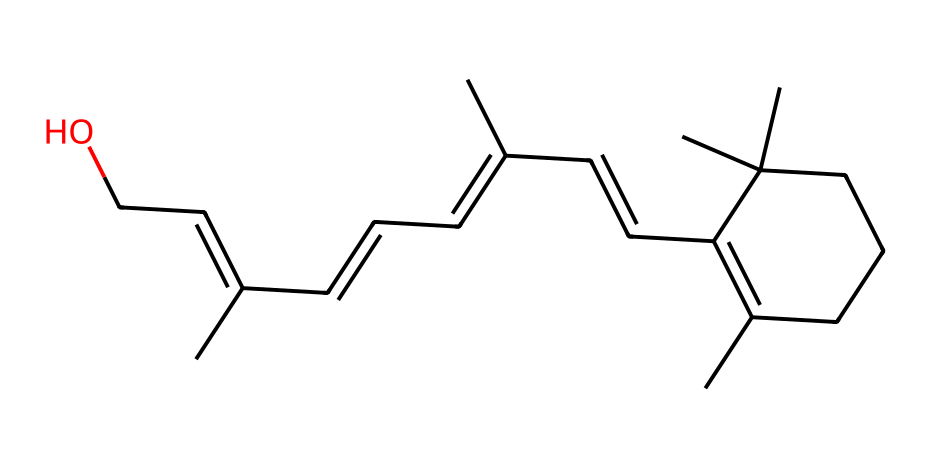What is the name of this chemical? The provided SMILES corresponds to retinol, which is commonly known as Vitamin A. The structure's overall arrangement and specific functional groups lead to its identification as retinol.
Answer: retinol How many carbon atoms are present in the structure? By analyzing the SMILES representation, you can count the number of 'C' characters in the chemical structure string. There are 20 carbon atoms in total.
Answer: 20 What functional group is present in this molecule? The molecule contains a hydroxyl (-OH) group, which is identified from the "C(CO)" part of the SMILES where 'O' indicates the presence of oxygen as part of the alcohol functional group.
Answer: hydroxyl How many double bonds are present in retinol? By examining the carbon-carbon connections in the structure, you can identify the presence of double bonds. In retinol, there are 5 double bonds between carbon atoms.
Answer: 5 Does this chemical dissolve in water? Since retinol is classified as a non-electrolyte, it has low solubility in water due to its hydrophobic carbon chain and the presence of less polar functional groups.
Answer: no What type of compound is retinol categorized as? Retinol is categorized as a non-electrolyte since it does not dissociate into ions in solution and has no charged groups that would conduct electricity.
Answer: non-electrolyte How many hydrogen atoms are present in retinol? The number of hydrogen atoms is determined by analyzing the structure according to the tetravalency of carbon and valency of the other atoms involved. The total count yields 30 hydrogen atoms.
Answer: 30 